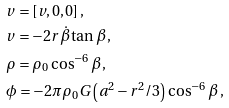Convert formula to latex. <formula><loc_0><loc_0><loc_500><loc_500>& v = [ v , 0 , 0 ] \, , \\ & v = - 2 r \dot { \beta } \tan \beta \, , \\ & \rho = \rho _ { 0 } \cos ^ { - 6 } \beta \, , \\ & \phi = - 2 \pi \rho _ { 0 } G \left ( a ^ { 2 } - r ^ { 2 } / 3 \right ) \cos ^ { - 6 } \beta \, ,</formula> 